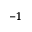Convert formula to latex. <formula><loc_0><loc_0><loc_500><loc_500>^ { - 1 }</formula> 